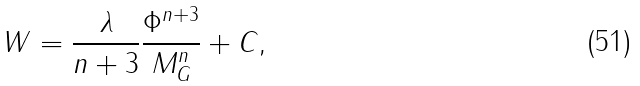<formula> <loc_0><loc_0><loc_500><loc_500>W = \frac { \lambda } { n + 3 } \frac { \Phi ^ { n + 3 } } { M _ { G } ^ { n } } + C ,</formula> 